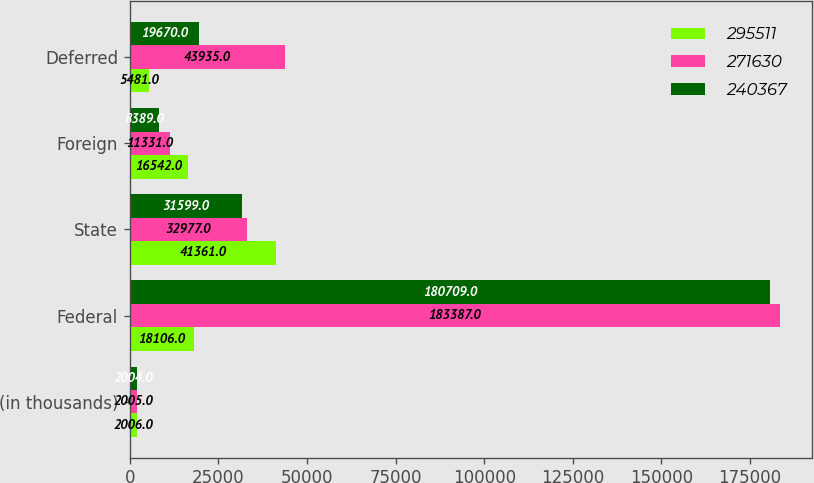Convert chart to OTSL. <chart><loc_0><loc_0><loc_500><loc_500><stacked_bar_chart><ecel><fcel>(in thousands)<fcel>Federal<fcel>State<fcel>Foreign<fcel>Deferred<nl><fcel>295511<fcel>2006<fcel>18106<fcel>41361<fcel>16542<fcel>5481<nl><fcel>271630<fcel>2005<fcel>183387<fcel>32977<fcel>11331<fcel>43935<nl><fcel>240367<fcel>2004<fcel>180709<fcel>31599<fcel>8389<fcel>19670<nl></chart> 